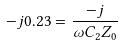Convert formula to latex. <formula><loc_0><loc_0><loc_500><loc_500>- j 0 . 2 3 = \frac { - j } { \omega C _ { 2 } Z _ { 0 } }</formula> 